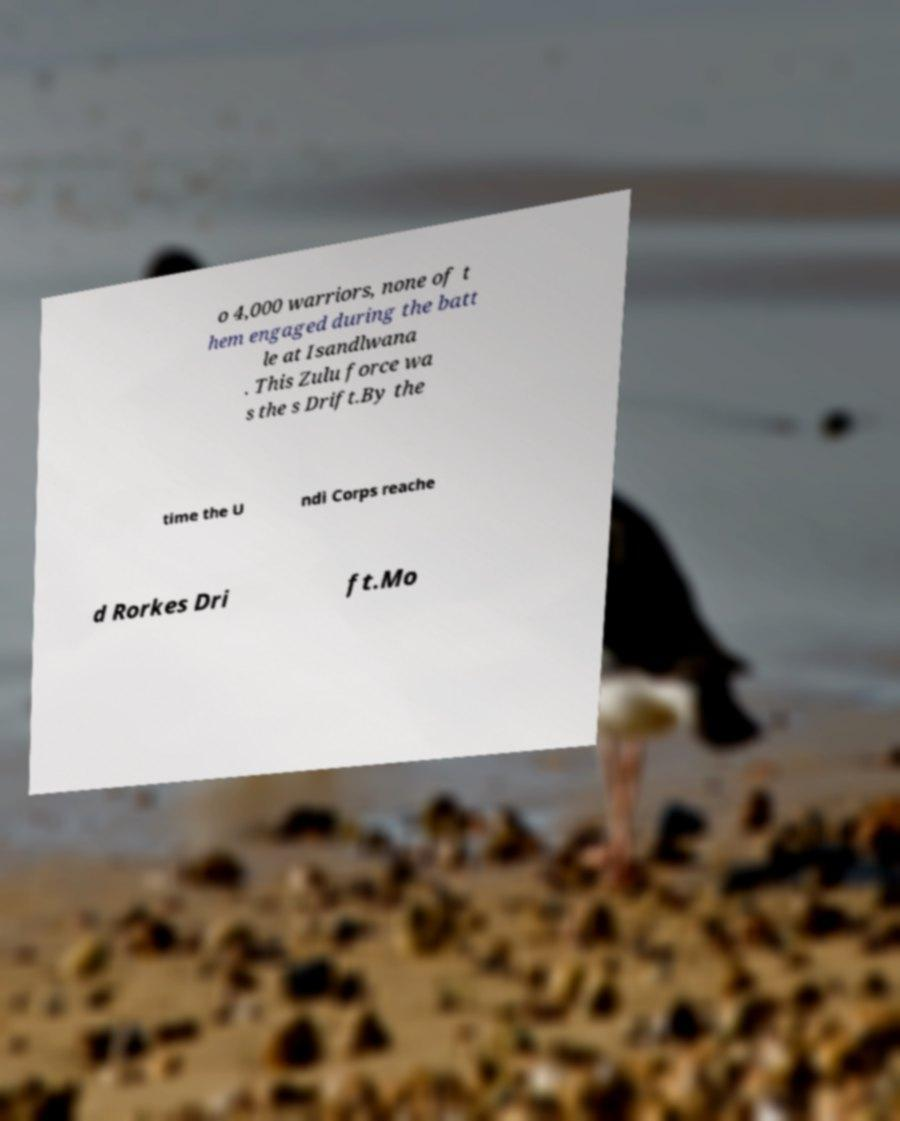There's text embedded in this image that I need extracted. Can you transcribe it verbatim? o 4,000 warriors, none of t hem engaged during the batt le at Isandlwana . This Zulu force wa s the s Drift.By the time the U ndi Corps reache d Rorkes Dri ft.Mo 